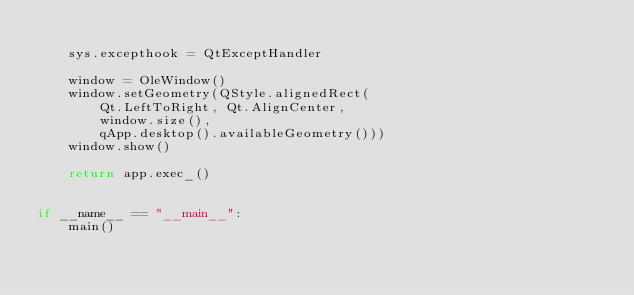Convert code to text. <code><loc_0><loc_0><loc_500><loc_500><_Python_>
    sys.excepthook = QtExceptHandler

    window = OleWindow()
    window.setGeometry(QStyle.alignedRect(
        Qt.LeftToRight, Qt.AlignCenter,
        window.size(),
        qApp.desktop().availableGeometry()))
    window.show()

    return app.exec_()


if __name__ == "__main__":
    main()
</code> 